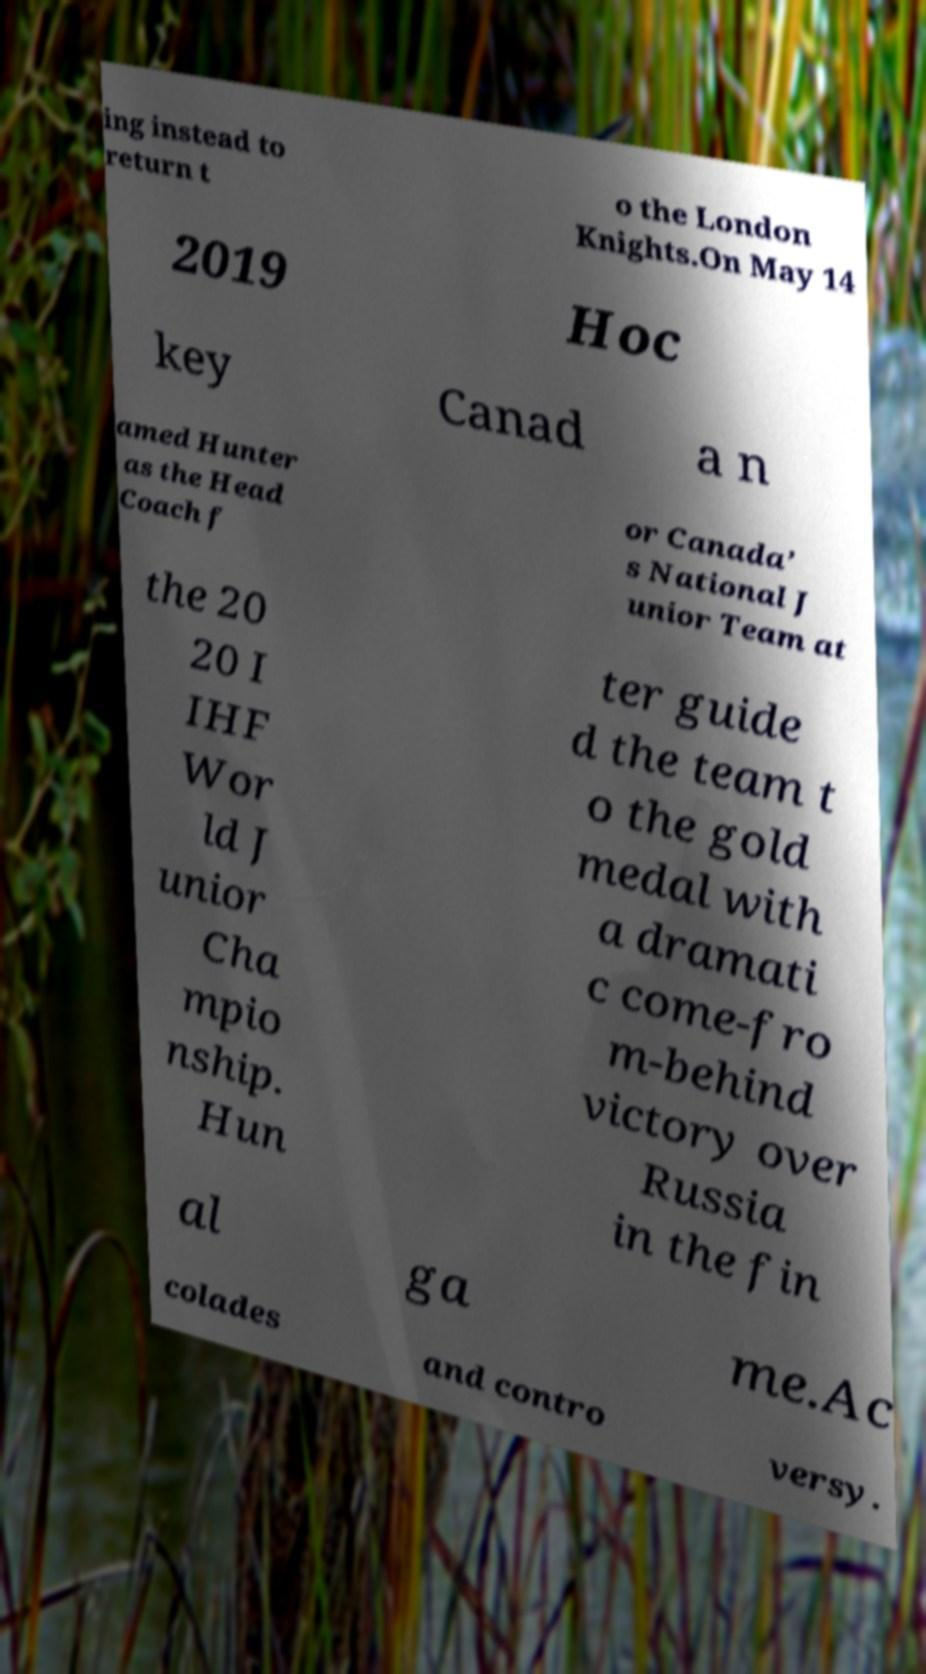Please identify and transcribe the text found in this image. ing instead to return t o the London Knights.On May 14 2019 Hoc key Canad a n amed Hunter as the Head Coach f or Canada’ s National J unior Team at the 20 20 I IHF Wor ld J unior Cha mpio nship. Hun ter guide d the team t o the gold medal with a dramati c come-fro m-behind victory over Russia in the fin al ga me.Ac colades and contro versy. 